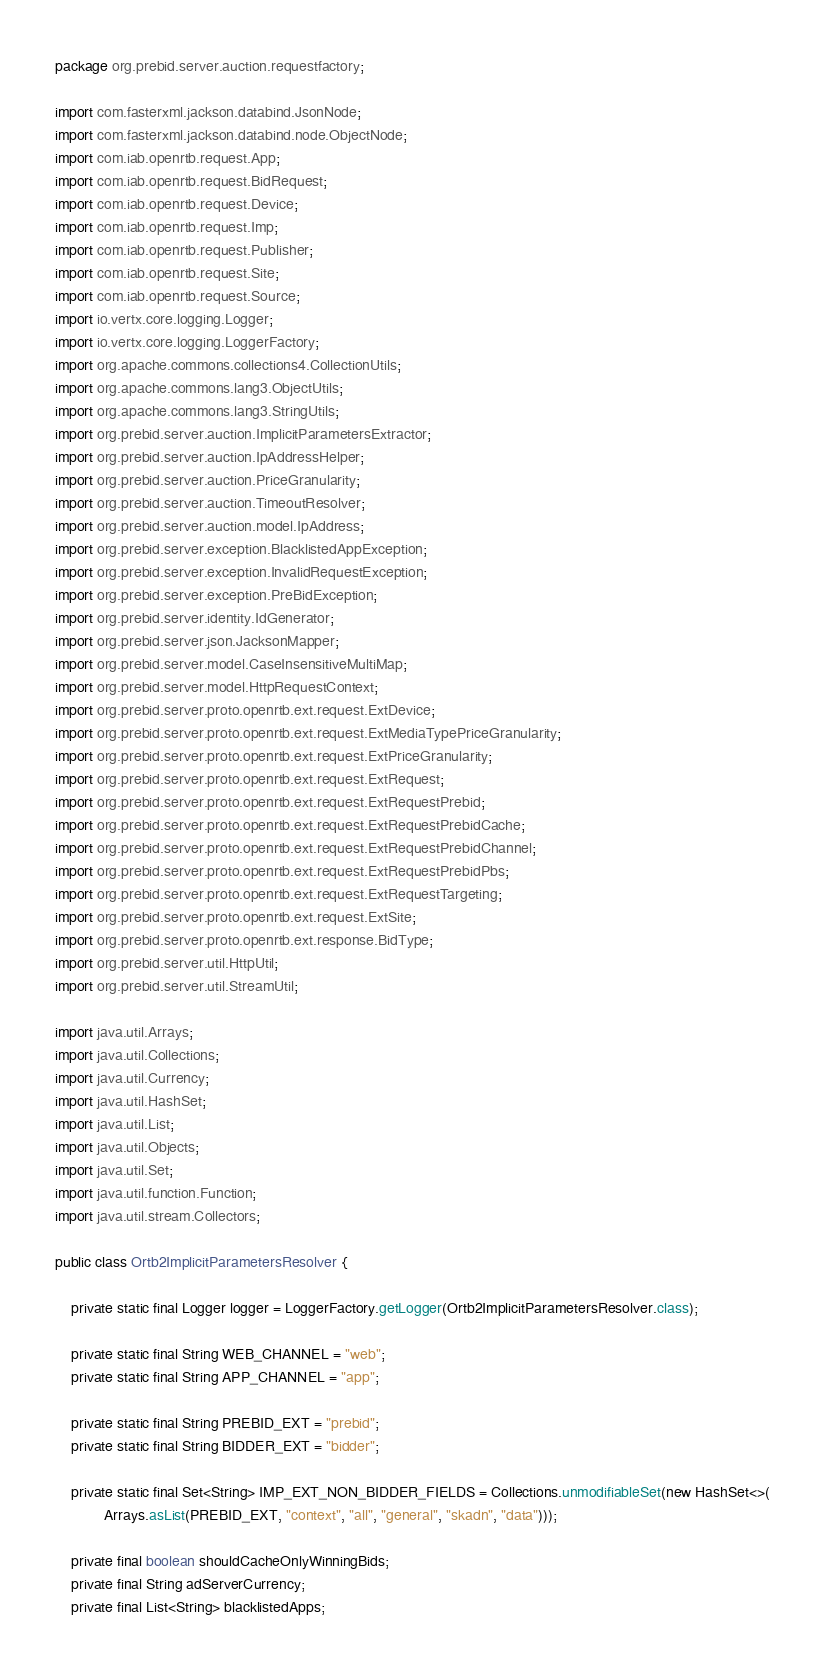Convert code to text. <code><loc_0><loc_0><loc_500><loc_500><_Java_>package org.prebid.server.auction.requestfactory;

import com.fasterxml.jackson.databind.JsonNode;
import com.fasterxml.jackson.databind.node.ObjectNode;
import com.iab.openrtb.request.App;
import com.iab.openrtb.request.BidRequest;
import com.iab.openrtb.request.Device;
import com.iab.openrtb.request.Imp;
import com.iab.openrtb.request.Publisher;
import com.iab.openrtb.request.Site;
import com.iab.openrtb.request.Source;
import io.vertx.core.logging.Logger;
import io.vertx.core.logging.LoggerFactory;
import org.apache.commons.collections4.CollectionUtils;
import org.apache.commons.lang3.ObjectUtils;
import org.apache.commons.lang3.StringUtils;
import org.prebid.server.auction.ImplicitParametersExtractor;
import org.prebid.server.auction.IpAddressHelper;
import org.prebid.server.auction.PriceGranularity;
import org.prebid.server.auction.TimeoutResolver;
import org.prebid.server.auction.model.IpAddress;
import org.prebid.server.exception.BlacklistedAppException;
import org.prebid.server.exception.InvalidRequestException;
import org.prebid.server.exception.PreBidException;
import org.prebid.server.identity.IdGenerator;
import org.prebid.server.json.JacksonMapper;
import org.prebid.server.model.CaseInsensitiveMultiMap;
import org.prebid.server.model.HttpRequestContext;
import org.prebid.server.proto.openrtb.ext.request.ExtDevice;
import org.prebid.server.proto.openrtb.ext.request.ExtMediaTypePriceGranularity;
import org.prebid.server.proto.openrtb.ext.request.ExtPriceGranularity;
import org.prebid.server.proto.openrtb.ext.request.ExtRequest;
import org.prebid.server.proto.openrtb.ext.request.ExtRequestPrebid;
import org.prebid.server.proto.openrtb.ext.request.ExtRequestPrebidCache;
import org.prebid.server.proto.openrtb.ext.request.ExtRequestPrebidChannel;
import org.prebid.server.proto.openrtb.ext.request.ExtRequestPrebidPbs;
import org.prebid.server.proto.openrtb.ext.request.ExtRequestTargeting;
import org.prebid.server.proto.openrtb.ext.request.ExtSite;
import org.prebid.server.proto.openrtb.ext.response.BidType;
import org.prebid.server.util.HttpUtil;
import org.prebid.server.util.StreamUtil;

import java.util.Arrays;
import java.util.Collections;
import java.util.Currency;
import java.util.HashSet;
import java.util.List;
import java.util.Objects;
import java.util.Set;
import java.util.function.Function;
import java.util.stream.Collectors;

public class Ortb2ImplicitParametersResolver {

    private static final Logger logger = LoggerFactory.getLogger(Ortb2ImplicitParametersResolver.class);

    private static final String WEB_CHANNEL = "web";
    private static final String APP_CHANNEL = "app";

    private static final String PREBID_EXT = "prebid";
    private static final String BIDDER_EXT = "bidder";

    private static final Set<String> IMP_EXT_NON_BIDDER_FIELDS = Collections.unmodifiableSet(new HashSet<>(
            Arrays.asList(PREBID_EXT, "context", "all", "general", "skadn", "data")));

    private final boolean shouldCacheOnlyWinningBids;
    private final String adServerCurrency;
    private final List<String> blacklistedApps;</code> 